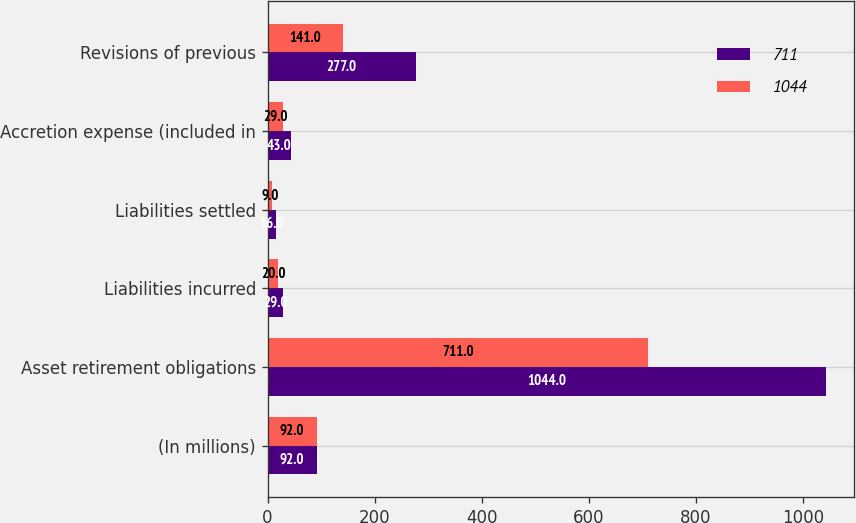<chart> <loc_0><loc_0><loc_500><loc_500><stacked_bar_chart><ecel><fcel>(In millions)<fcel>Asset retirement obligations<fcel>Liabilities incurred<fcel>Liabilities settled<fcel>Accretion expense (included in<fcel>Revisions of previous<nl><fcel>711<fcel>92<fcel>1044<fcel>29<fcel>16<fcel>43<fcel>277<nl><fcel>1044<fcel>92<fcel>711<fcel>20<fcel>9<fcel>29<fcel>141<nl></chart> 